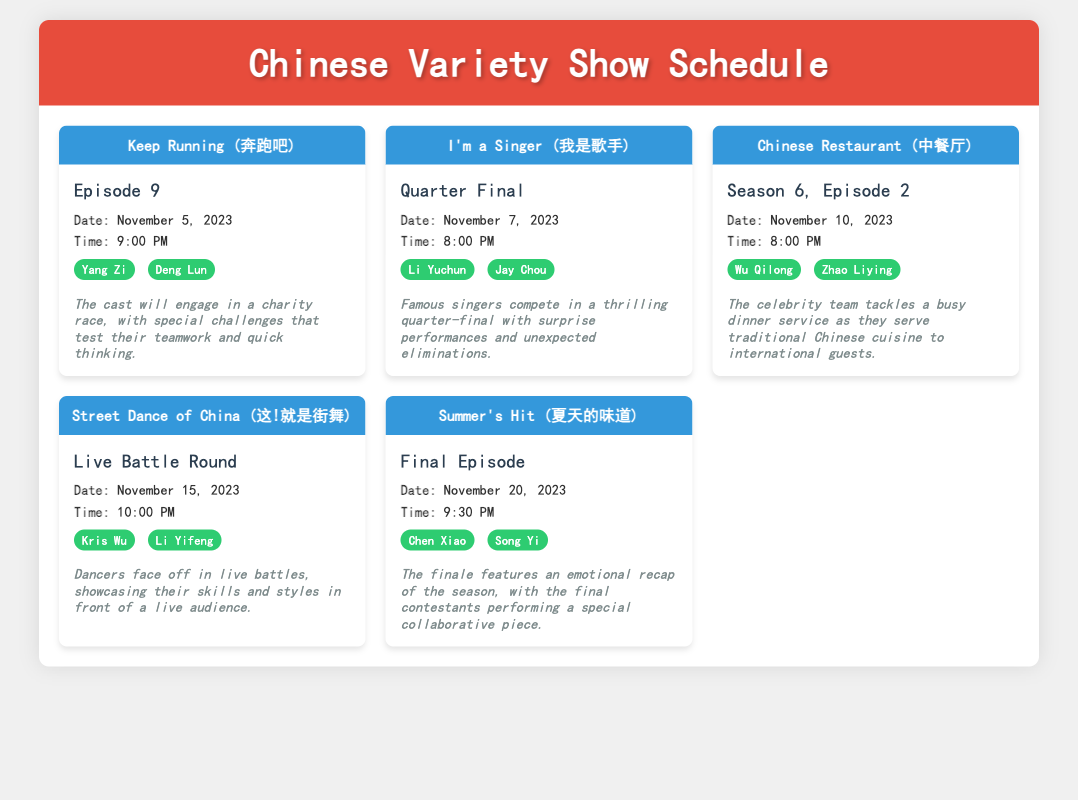what is the title of the show airing on November 5, 2023? The title of the show on that date is "Keep Running (奔跑吧)".
Answer: Keep Running (奔跑吧) who are the guests featured in the episode on November 10, 2023? The guests for this episode are Wu Qilong and Zhao Liying.
Answer: Wu Qilong, Zhao Liying what time does the "I'm a Singer" quarter-final air? The show airs at 8:00 PM on that day.
Answer: 8:00 PM how many episodes are there in the current season of "Chinese Restaurant"? This is season 6, and the specific episode listed is episode 2.
Answer: Episode 2 which show features a charity race? The show that features a charity race is "Keep Running (奔跑吧)".
Answer: Keep Running (奔跑吧) what is the highlight of the "Street Dance of China" episode? The highlight involves dancers facing off in live battles in front of an audience.
Answer: Live battles when is the finale of "Summer's Hit" scheduled? The finale is scheduled for November 20, 2023.
Answer: November 20, 2023 who are the two guests appearing in the finale of "Summer's Hit"? The guests are Chen Xiao and Song Yi.
Answer: Chen Xiao, Song Yi what type of performance is featured in the "I'm a Singer" quarter-final? The performance features surprise performances and unexpected eliminations.
Answer: Surprise performances 